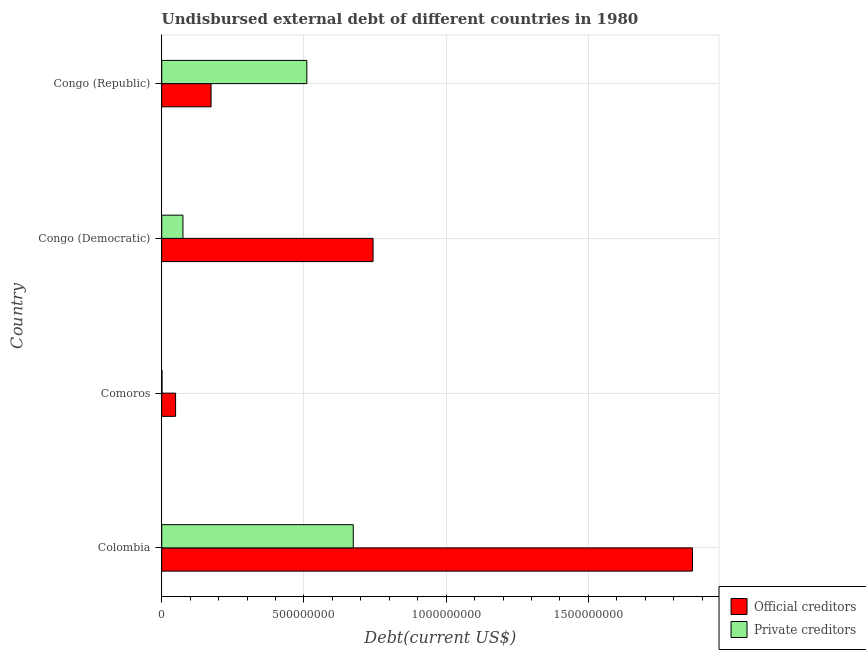How many different coloured bars are there?
Your answer should be compact. 2. How many groups of bars are there?
Your answer should be very brief. 4. Are the number of bars per tick equal to the number of legend labels?
Make the answer very short. Yes. What is the label of the 1st group of bars from the top?
Your response must be concise. Congo (Republic). What is the undisbursed external debt of private creditors in Congo (Republic)?
Offer a very short reply. 5.10e+08. Across all countries, what is the maximum undisbursed external debt of official creditors?
Your answer should be very brief. 1.87e+09. Across all countries, what is the minimum undisbursed external debt of official creditors?
Provide a short and direct response. 4.88e+07. In which country was the undisbursed external debt of private creditors minimum?
Ensure brevity in your answer.  Comoros. What is the total undisbursed external debt of private creditors in the graph?
Your answer should be very brief. 1.26e+09. What is the difference between the undisbursed external debt of official creditors in Congo (Democratic) and that in Congo (Republic)?
Your answer should be compact. 5.70e+08. What is the difference between the undisbursed external debt of private creditors in Colombia and the undisbursed external debt of official creditors in Congo (Democratic)?
Make the answer very short. -6.96e+07. What is the average undisbursed external debt of official creditors per country?
Your answer should be compact. 7.08e+08. What is the difference between the undisbursed external debt of official creditors and undisbursed external debt of private creditors in Colombia?
Offer a very short reply. 1.19e+09. In how many countries, is the undisbursed external debt of private creditors greater than 500000000 US$?
Offer a very short reply. 2. What is the ratio of the undisbursed external debt of private creditors in Colombia to that in Congo (Republic)?
Keep it short and to the point. 1.32. What is the difference between the highest and the second highest undisbursed external debt of private creditors?
Offer a very short reply. 1.63e+08. What is the difference between the highest and the lowest undisbursed external debt of private creditors?
Offer a terse response. 6.72e+08. In how many countries, is the undisbursed external debt of private creditors greater than the average undisbursed external debt of private creditors taken over all countries?
Provide a short and direct response. 2. Is the sum of the undisbursed external debt of official creditors in Comoros and Congo (Republic) greater than the maximum undisbursed external debt of private creditors across all countries?
Offer a terse response. No. What does the 1st bar from the top in Congo (Democratic) represents?
Provide a short and direct response. Private creditors. What does the 1st bar from the bottom in Colombia represents?
Your answer should be very brief. Official creditors. Are all the bars in the graph horizontal?
Give a very brief answer. Yes. What is the difference between two consecutive major ticks on the X-axis?
Ensure brevity in your answer.  5.00e+08. Does the graph contain any zero values?
Offer a terse response. No. Does the graph contain grids?
Make the answer very short. Yes. Where does the legend appear in the graph?
Make the answer very short. Bottom right. How are the legend labels stacked?
Your answer should be compact. Vertical. What is the title of the graph?
Offer a very short reply. Undisbursed external debt of different countries in 1980. What is the label or title of the X-axis?
Your answer should be very brief. Debt(current US$). What is the Debt(current US$) of Official creditors in Colombia?
Ensure brevity in your answer.  1.87e+09. What is the Debt(current US$) of Private creditors in Colombia?
Offer a very short reply. 6.73e+08. What is the Debt(current US$) in Official creditors in Comoros?
Keep it short and to the point. 4.88e+07. What is the Debt(current US$) of Private creditors in Comoros?
Provide a succinct answer. 9.98e+05. What is the Debt(current US$) of Official creditors in Congo (Democratic)?
Keep it short and to the point. 7.43e+08. What is the Debt(current US$) of Private creditors in Congo (Democratic)?
Provide a succinct answer. 7.47e+07. What is the Debt(current US$) of Official creditors in Congo (Republic)?
Your response must be concise. 1.73e+08. What is the Debt(current US$) in Private creditors in Congo (Republic)?
Give a very brief answer. 5.10e+08. Across all countries, what is the maximum Debt(current US$) of Official creditors?
Offer a very short reply. 1.87e+09. Across all countries, what is the maximum Debt(current US$) in Private creditors?
Offer a terse response. 6.73e+08. Across all countries, what is the minimum Debt(current US$) in Official creditors?
Provide a succinct answer. 4.88e+07. Across all countries, what is the minimum Debt(current US$) of Private creditors?
Ensure brevity in your answer.  9.98e+05. What is the total Debt(current US$) in Official creditors in the graph?
Your answer should be very brief. 2.83e+09. What is the total Debt(current US$) in Private creditors in the graph?
Offer a terse response. 1.26e+09. What is the difference between the Debt(current US$) of Official creditors in Colombia and that in Comoros?
Ensure brevity in your answer.  1.82e+09. What is the difference between the Debt(current US$) of Private creditors in Colombia and that in Comoros?
Make the answer very short. 6.72e+08. What is the difference between the Debt(current US$) of Official creditors in Colombia and that in Congo (Democratic)?
Your answer should be very brief. 1.12e+09. What is the difference between the Debt(current US$) in Private creditors in Colombia and that in Congo (Democratic)?
Keep it short and to the point. 5.99e+08. What is the difference between the Debt(current US$) of Official creditors in Colombia and that in Congo (Republic)?
Offer a very short reply. 1.69e+09. What is the difference between the Debt(current US$) of Private creditors in Colombia and that in Congo (Republic)?
Give a very brief answer. 1.63e+08. What is the difference between the Debt(current US$) of Official creditors in Comoros and that in Congo (Democratic)?
Offer a very short reply. -6.94e+08. What is the difference between the Debt(current US$) of Private creditors in Comoros and that in Congo (Democratic)?
Give a very brief answer. -7.37e+07. What is the difference between the Debt(current US$) in Official creditors in Comoros and that in Congo (Republic)?
Offer a very short reply. -1.25e+08. What is the difference between the Debt(current US$) of Private creditors in Comoros and that in Congo (Republic)?
Your response must be concise. -5.09e+08. What is the difference between the Debt(current US$) of Official creditors in Congo (Democratic) and that in Congo (Republic)?
Your response must be concise. 5.70e+08. What is the difference between the Debt(current US$) in Private creditors in Congo (Democratic) and that in Congo (Republic)?
Provide a short and direct response. -4.36e+08. What is the difference between the Debt(current US$) in Official creditors in Colombia and the Debt(current US$) in Private creditors in Comoros?
Offer a very short reply. 1.87e+09. What is the difference between the Debt(current US$) in Official creditors in Colombia and the Debt(current US$) in Private creditors in Congo (Democratic)?
Keep it short and to the point. 1.79e+09. What is the difference between the Debt(current US$) in Official creditors in Colombia and the Debt(current US$) in Private creditors in Congo (Republic)?
Your response must be concise. 1.36e+09. What is the difference between the Debt(current US$) in Official creditors in Comoros and the Debt(current US$) in Private creditors in Congo (Democratic)?
Your answer should be very brief. -2.58e+07. What is the difference between the Debt(current US$) of Official creditors in Comoros and the Debt(current US$) of Private creditors in Congo (Republic)?
Provide a short and direct response. -4.61e+08. What is the difference between the Debt(current US$) of Official creditors in Congo (Democratic) and the Debt(current US$) of Private creditors in Congo (Republic)?
Provide a succinct answer. 2.33e+08. What is the average Debt(current US$) of Official creditors per country?
Give a very brief answer. 7.08e+08. What is the average Debt(current US$) in Private creditors per country?
Offer a very short reply. 3.15e+08. What is the difference between the Debt(current US$) of Official creditors and Debt(current US$) of Private creditors in Colombia?
Your answer should be very brief. 1.19e+09. What is the difference between the Debt(current US$) in Official creditors and Debt(current US$) in Private creditors in Comoros?
Ensure brevity in your answer.  4.78e+07. What is the difference between the Debt(current US$) of Official creditors and Debt(current US$) of Private creditors in Congo (Democratic)?
Provide a short and direct response. 6.68e+08. What is the difference between the Debt(current US$) of Official creditors and Debt(current US$) of Private creditors in Congo (Republic)?
Give a very brief answer. -3.37e+08. What is the ratio of the Debt(current US$) in Official creditors in Colombia to that in Comoros?
Give a very brief answer. 38.22. What is the ratio of the Debt(current US$) in Private creditors in Colombia to that in Comoros?
Your response must be concise. 674.81. What is the ratio of the Debt(current US$) of Official creditors in Colombia to that in Congo (Democratic)?
Provide a succinct answer. 2.51. What is the ratio of the Debt(current US$) of Private creditors in Colombia to that in Congo (Democratic)?
Offer a terse response. 9.02. What is the ratio of the Debt(current US$) in Official creditors in Colombia to that in Congo (Republic)?
Give a very brief answer. 10.76. What is the ratio of the Debt(current US$) in Private creditors in Colombia to that in Congo (Republic)?
Provide a short and direct response. 1.32. What is the ratio of the Debt(current US$) in Official creditors in Comoros to that in Congo (Democratic)?
Offer a very short reply. 0.07. What is the ratio of the Debt(current US$) of Private creditors in Comoros to that in Congo (Democratic)?
Keep it short and to the point. 0.01. What is the ratio of the Debt(current US$) in Official creditors in Comoros to that in Congo (Republic)?
Offer a very short reply. 0.28. What is the ratio of the Debt(current US$) in Private creditors in Comoros to that in Congo (Republic)?
Offer a terse response. 0. What is the ratio of the Debt(current US$) of Official creditors in Congo (Democratic) to that in Congo (Republic)?
Ensure brevity in your answer.  4.28. What is the ratio of the Debt(current US$) of Private creditors in Congo (Democratic) to that in Congo (Republic)?
Offer a very short reply. 0.15. What is the difference between the highest and the second highest Debt(current US$) of Official creditors?
Offer a terse response. 1.12e+09. What is the difference between the highest and the second highest Debt(current US$) in Private creditors?
Give a very brief answer. 1.63e+08. What is the difference between the highest and the lowest Debt(current US$) in Official creditors?
Your answer should be compact. 1.82e+09. What is the difference between the highest and the lowest Debt(current US$) of Private creditors?
Offer a terse response. 6.72e+08. 